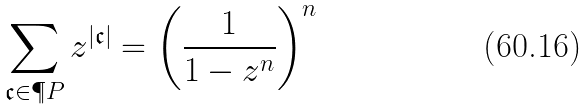<formula> <loc_0><loc_0><loc_500><loc_500>\sum _ { \mathfrak { c } \in \P P } z ^ { | \mathfrak { c } | } = \left ( \frac { 1 } { 1 - z ^ { n } } \right ) ^ { n }</formula> 